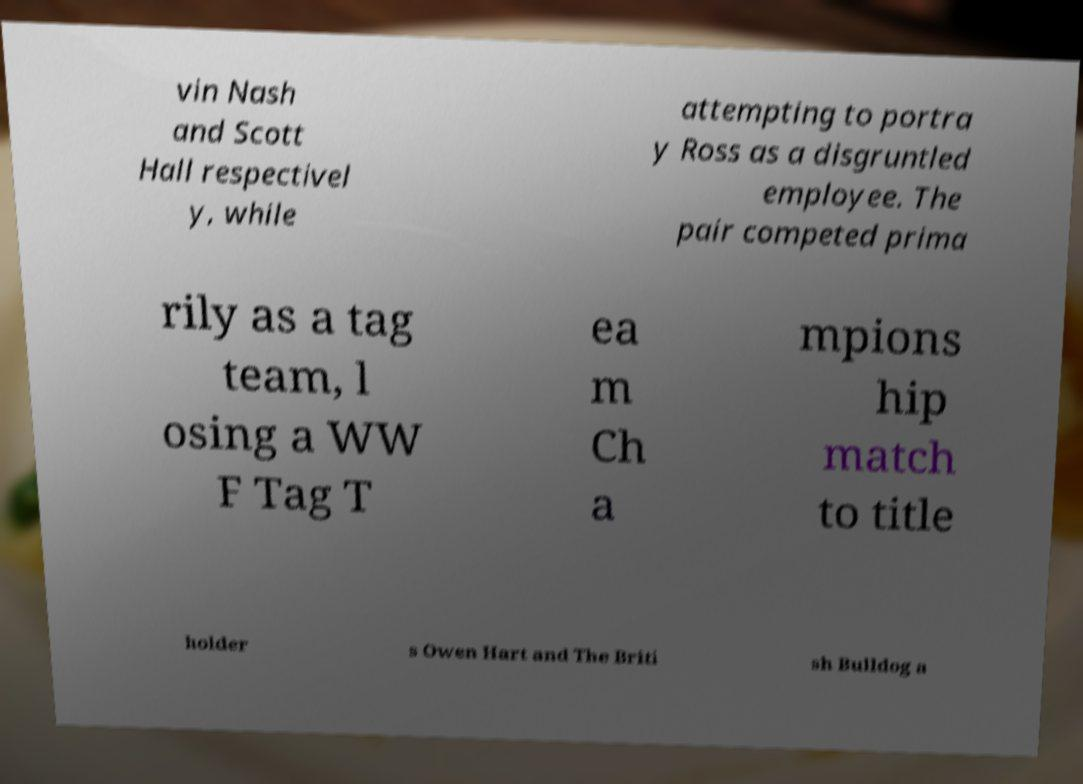Can you read and provide the text displayed in the image?This photo seems to have some interesting text. Can you extract and type it out for me? vin Nash and Scott Hall respectivel y, while attempting to portra y Ross as a disgruntled employee. The pair competed prima rily as a tag team, l osing a WW F Tag T ea m Ch a mpions hip match to title holder s Owen Hart and The Briti sh Bulldog a 